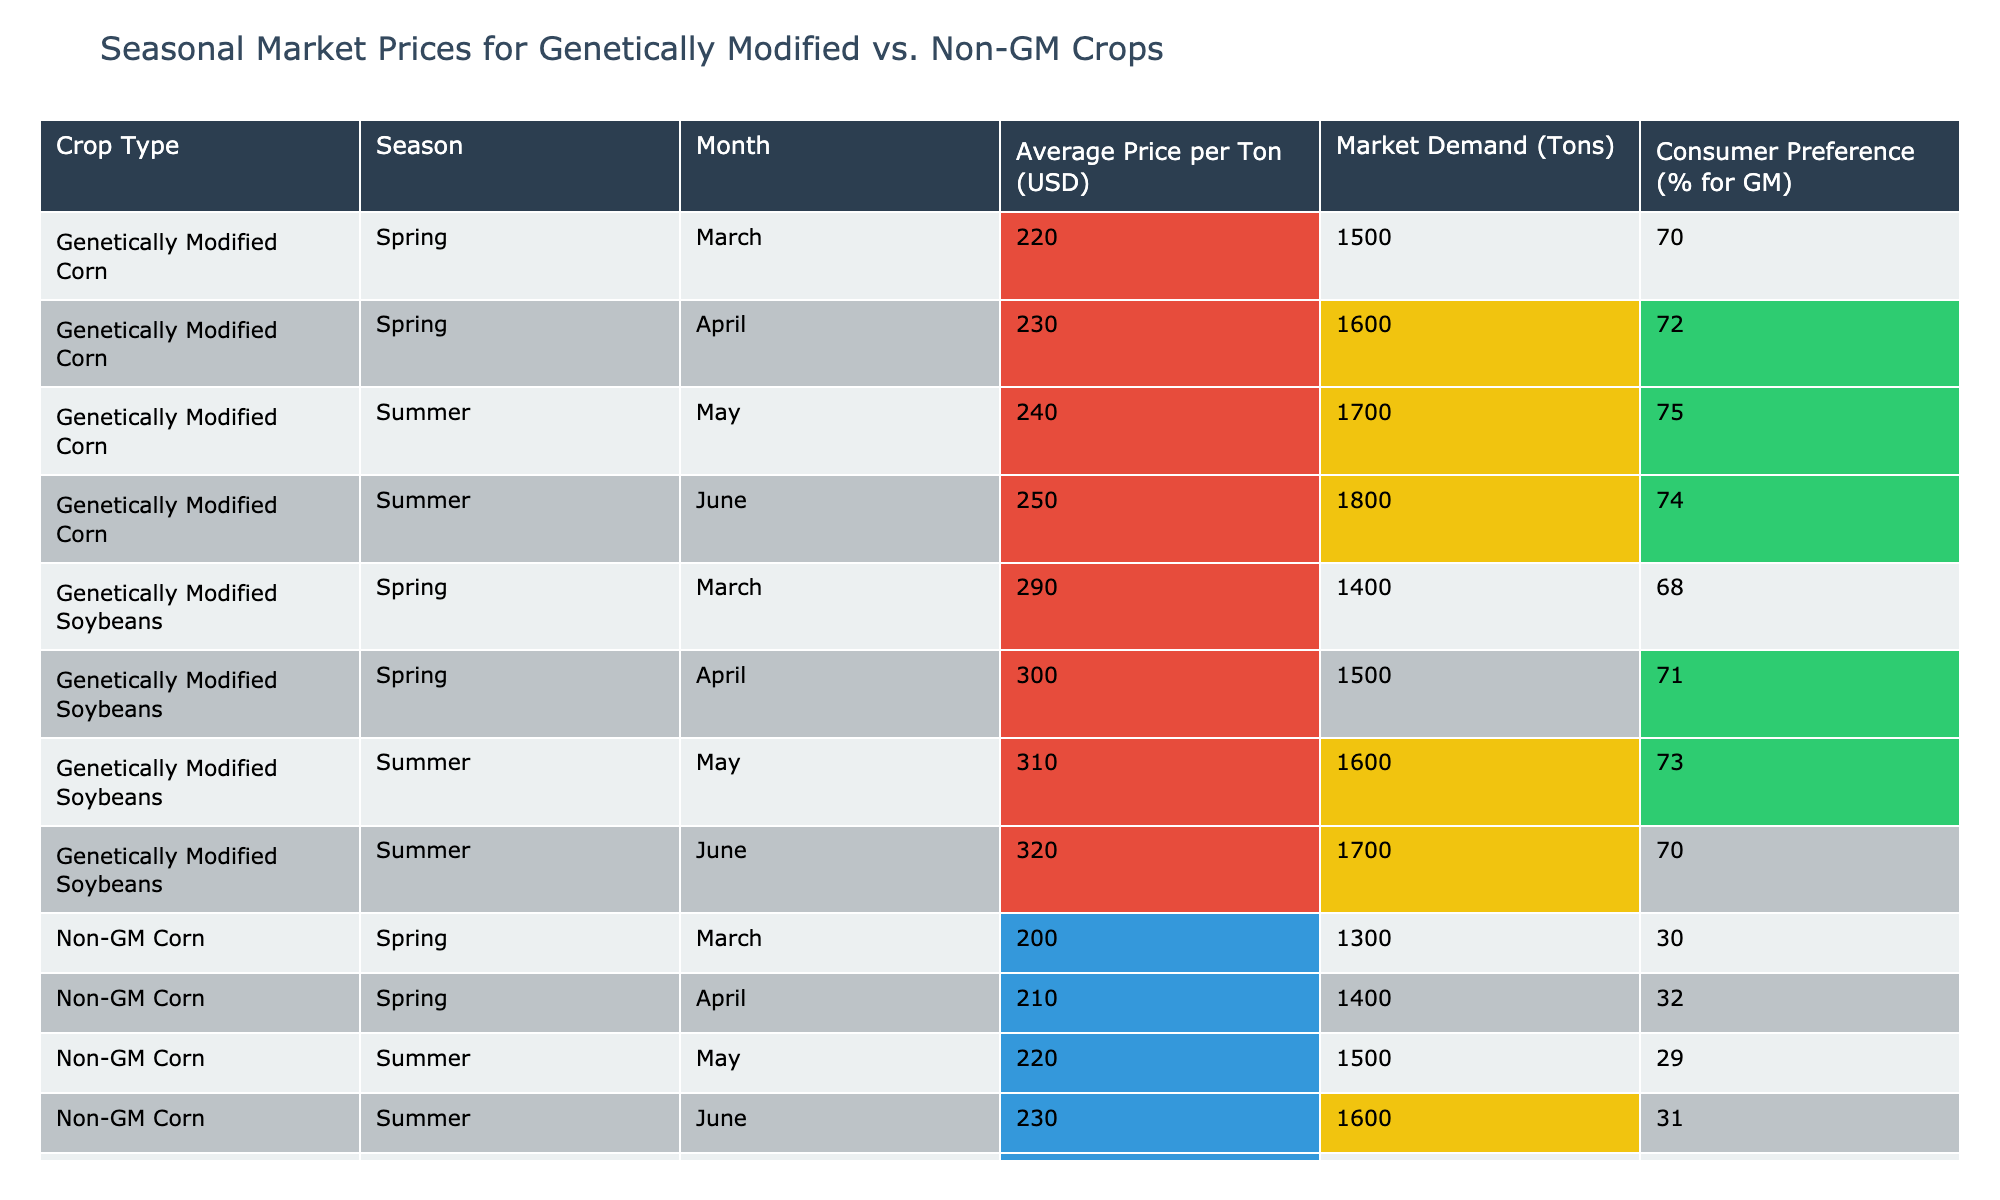What is the average price per ton for genetically modified corn in the summer? The average price per ton for genetically modified corn in the summer is calculated by taking the prices in May (240) and June (250) and finding the average: (240 + 250) / 2 = 245.
Answer: 245 How many tons of genetically modified soybeans were demanded in April? In April, the market demand for genetically modified soybeans was 1500 tons, as indicated in the data.
Answer: 1500 Which crop type had a higher average price per ton in March, genetically modified corn or non-GM corn? The average price for genetically modified corn in March was 220 USD, while for non-GM corn it was 200 USD. Thus, genetically modified corn had a higher average price.
Answer: Yes What is the difference in market demand between non-GM soybeans in June and genetically modified soybeans in June? The market demand for non-GM soybeans in June is 1500 tons and for genetically modified soybeans in June is 1700 tons. The difference is calculated as 1700 - 1500 = 200 tons.
Answer: 200 In which season did genetically modified corn have the highest market demand? The highest market demand for genetically modified corn was in June during the summer, with 1800 tons, which is the highest value in the demand column for that crop type.
Answer: Summer What percent of consumers preferred genetically modified corn in April compared to non-GM corn in April? Genetically modified corn had a consumer preference of 72% in April, while non-GM corn had 32% preference. Therefore, genetically modified corn had a higher preference difference of 72 - 32 = 40%.
Answer: 40% What is the total market demand for non-GM corn across both spring months? The total market demand for non-GM corn in March is 1300 tons and in April is 1400 tons. Adding these gives 1300 + 1400 = 2700 tons as the total demand.
Answer: 2700 Which crop type had the overall highest average price per ton in the summer months? In the summer months, genetically modified soybeans averaged prices of (310 + 320) / 2 = 315 USD, while genetically modified corn averaged (240 + 250) / 2 = 245 USD, and non-GM corn averaged (220 + 230) / 2 = 225 USD, making genetically modified soybeans the highest at 315 USD.
Answer: Genetically modified soybeans How much was the average price increase for non-GM soybeans from March to April? Non-GM soybeans had prices of 270 USD in March and 280 USD in April. The increase is calculated as 280 - 270 = 10 USD.
Answer: 10 Is the consumer preference for genetically modified soybeans higher in summer compared to spring? In summer, the consumer preference for genetically modified soybeans is 73% in May and 70% in June, while in spring it was 68% in March and 71% in April. The average preference for summer is (73 + 70) / 2 = 71.5% which is compared against spring's 69.5% average. Thus, yes, summer preference is higher.
Answer: Yes 